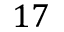<formula> <loc_0><loc_0><loc_500><loc_500>1 7</formula> 